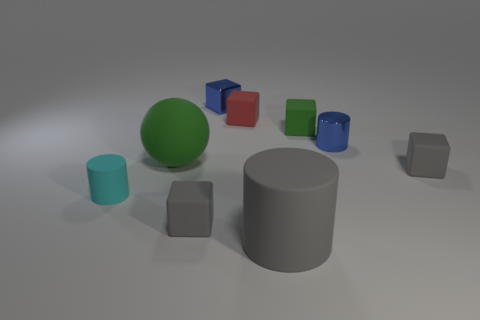What is the size of the object that is both left of the small blue block and on the right side of the green ball? The object to the left of the small blue block and on the right side of the green ball is a small grey block. Its size appears to be roughly the same as the other small blocks situated across the scene, characterized by its compact and cube-like structure, which can be visually estimated to be comparable to the other small cubes. 